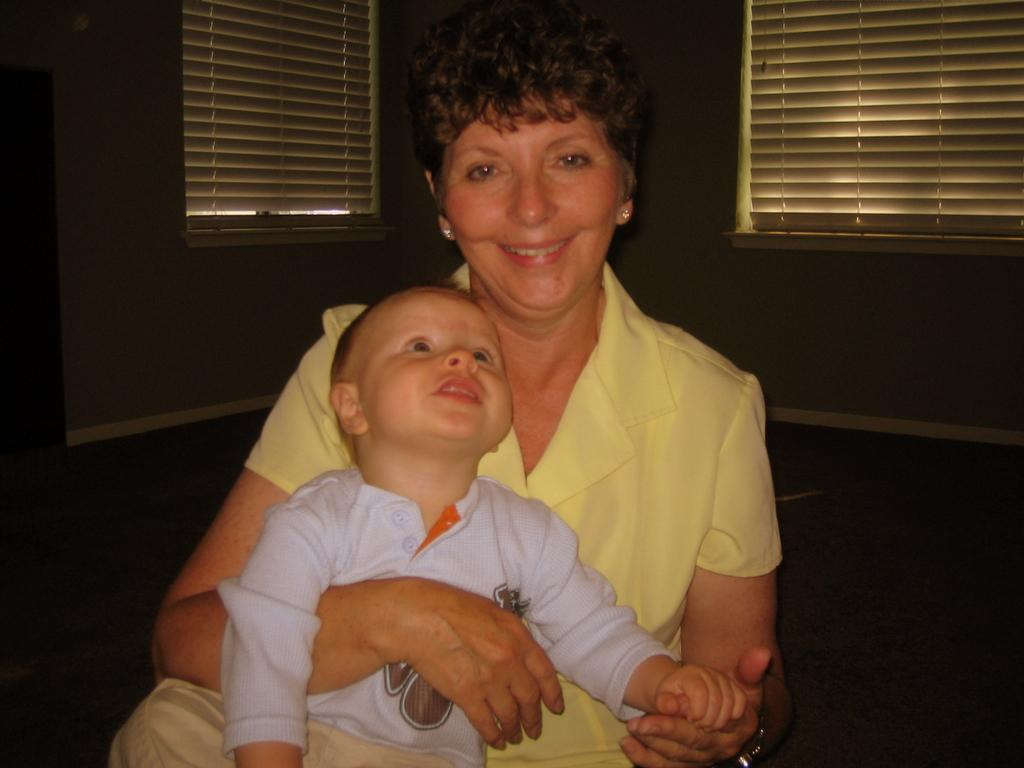What is happening in the center of the image? There is a lady holding a boy in the center of the image. What can be seen in the background of the image? There is a window and a wall in the background of the image. What type of cord is being used by the lady to hold the boy in the image? There is no cord present in the image; the lady is holding the boy with her arms. 